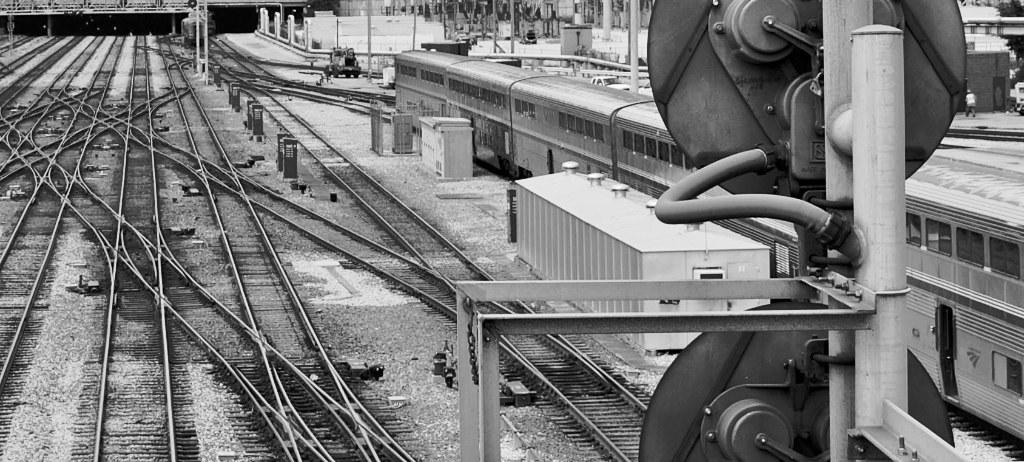What can be seen on the left side of the image? There are railway tracks on the left side of the image. What is located on the right side of the image? There is a train on the right side of the image. How are the railway tracks and the train related in the image? The railway tracks are the path on which the train is traveling. What type of dirt can be seen on the trail in the image? There is no trail or dirt present in the image; it features railway tracks and a train. 